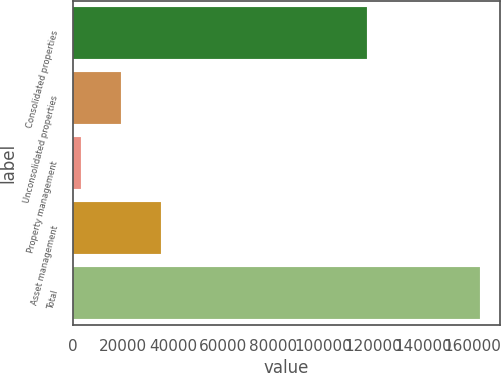Convert chart to OTSL. <chart><loc_0><loc_0><loc_500><loc_500><bar_chart><fcel>Consolidated properties<fcel>Unconsolidated properties<fcel>Property management<fcel>Asset management<fcel>Total<nl><fcel>117719<fcel>19207.5<fcel>3252<fcel>35163<fcel>162807<nl></chart> 